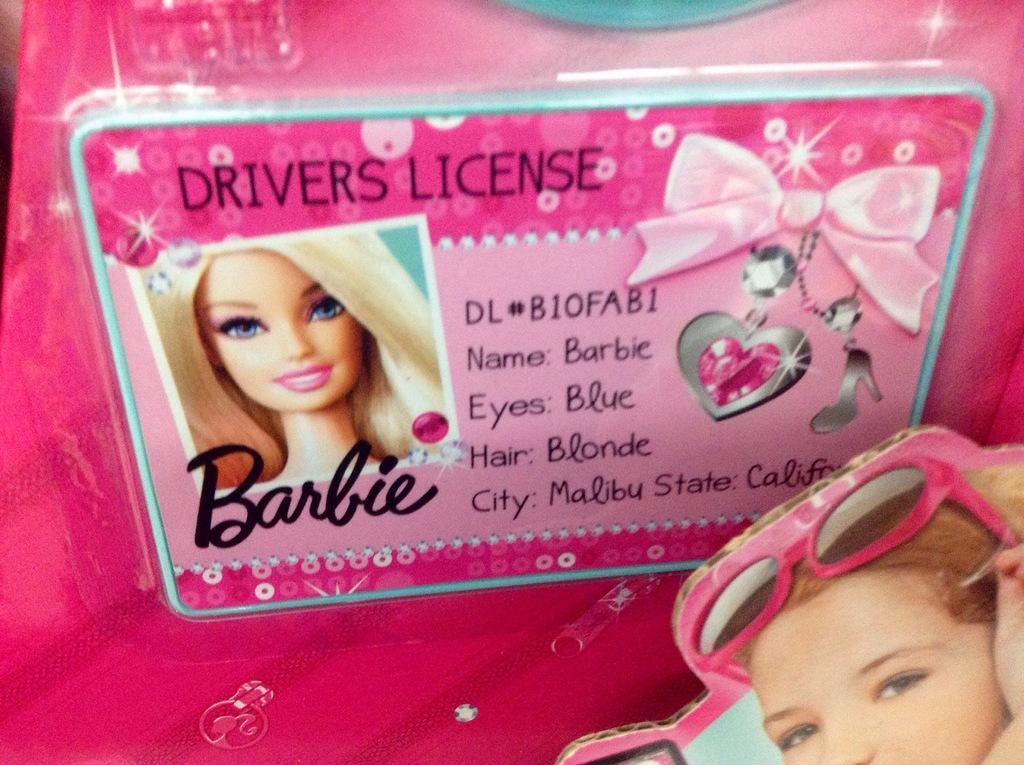What is the main feature of the image? The image contains a cover. What type of image is on the cover? There is a cartoon picture and a girl's picture on the cover. Are there any words on the cover? Yes, there is text on the cover. How many crows are depicted on the cover? There is no crow present on the cover; it features a cartoon picture and a girl's picture. What type of mitten is the girl holding on the cover? There is no mitten present on the cover; the girl's picture does not show her holding a mitten. 